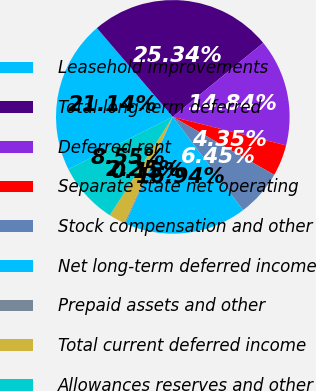Convert chart to OTSL. <chart><loc_0><loc_0><loc_500><loc_500><pie_chart><fcel>Leasehold improvements<fcel>Total long-term deferred<fcel>Deferred rent<fcel>Separate state net operating<fcel>Stock compensation and other<fcel>Net long-term deferred income<fcel>Prepaid assets and other<fcel>Total current deferred income<fcel>Allowances reserves and other<nl><fcel>21.14%<fcel>25.34%<fcel>14.84%<fcel>4.35%<fcel>6.45%<fcel>16.94%<fcel>0.15%<fcel>2.25%<fcel>8.55%<nl></chart> 